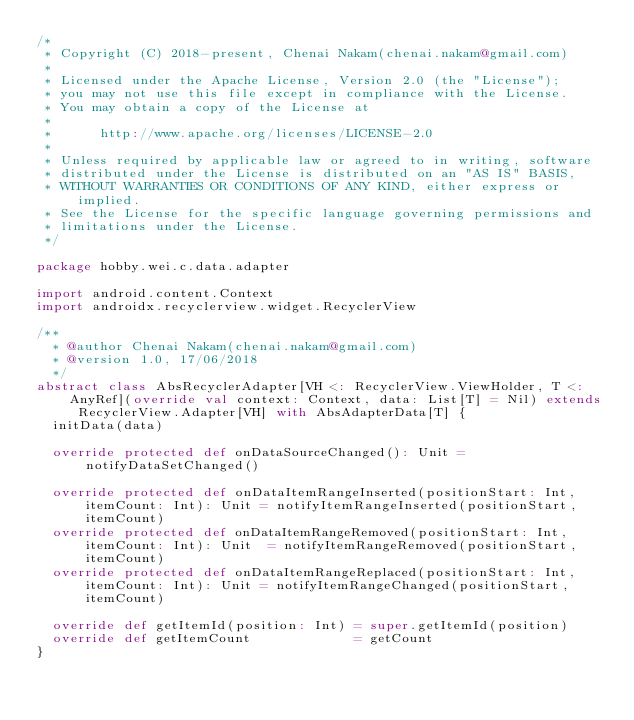<code> <loc_0><loc_0><loc_500><loc_500><_Scala_>/*
 * Copyright (C) 2018-present, Chenai Nakam(chenai.nakam@gmail.com)
 *
 * Licensed under the Apache License, Version 2.0 (the "License");
 * you may not use this file except in compliance with the License.
 * You may obtain a copy of the License at
 *
 *      http://www.apache.org/licenses/LICENSE-2.0
 *
 * Unless required by applicable law or agreed to in writing, software
 * distributed under the License is distributed on an "AS IS" BASIS,
 * WITHOUT WARRANTIES OR CONDITIONS OF ANY KIND, either express or implied.
 * See the License for the specific language governing permissions and
 * limitations under the License.
 */

package hobby.wei.c.data.adapter

import android.content.Context
import androidx.recyclerview.widget.RecyclerView

/**
  * @author Chenai Nakam(chenai.nakam@gmail.com)
  * @version 1.0, 17/06/2018
  */
abstract class AbsRecyclerAdapter[VH <: RecyclerView.ViewHolder, T <: AnyRef](override val context: Context, data: List[T] = Nil) extends RecyclerView.Adapter[VH] with AbsAdapterData[T] {
  initData(data)

  override protected def onDataSourceChanged(): Unit = notifyDataSetChanged()

  override protected def onDataItemRangeInserted(positionStart: Int, itemCount: Int): Unit = notifyItemRangeInserted(positionStart, itemCount)
  override protected def onDataItemRangeRemoved(positionStart: Int, itemCount: Int): Unit  = notifyItemRangeRemoved(positionStart, itemCount)
  override protected def onDataItemRangeReplaced(positionStart: Int, itemCount: Int): Unit = notifyItemRangeChanged(positionStart, itemCount)

  override def getItemId(position: Int) = super.getItemId(position)
  override def getItemCount             = getCount
}
</code> 